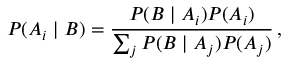<formula> <loc_0><loc_0><loc_500><loc_500>P ( A _ { i } | B ) = { \frac { P ( B | A _ { i } ) P ( A _ { i } ) } { \sum _ { j } P ( B | A _ { j } ) P ( A _ { j } ) } } \, ,</formula> 